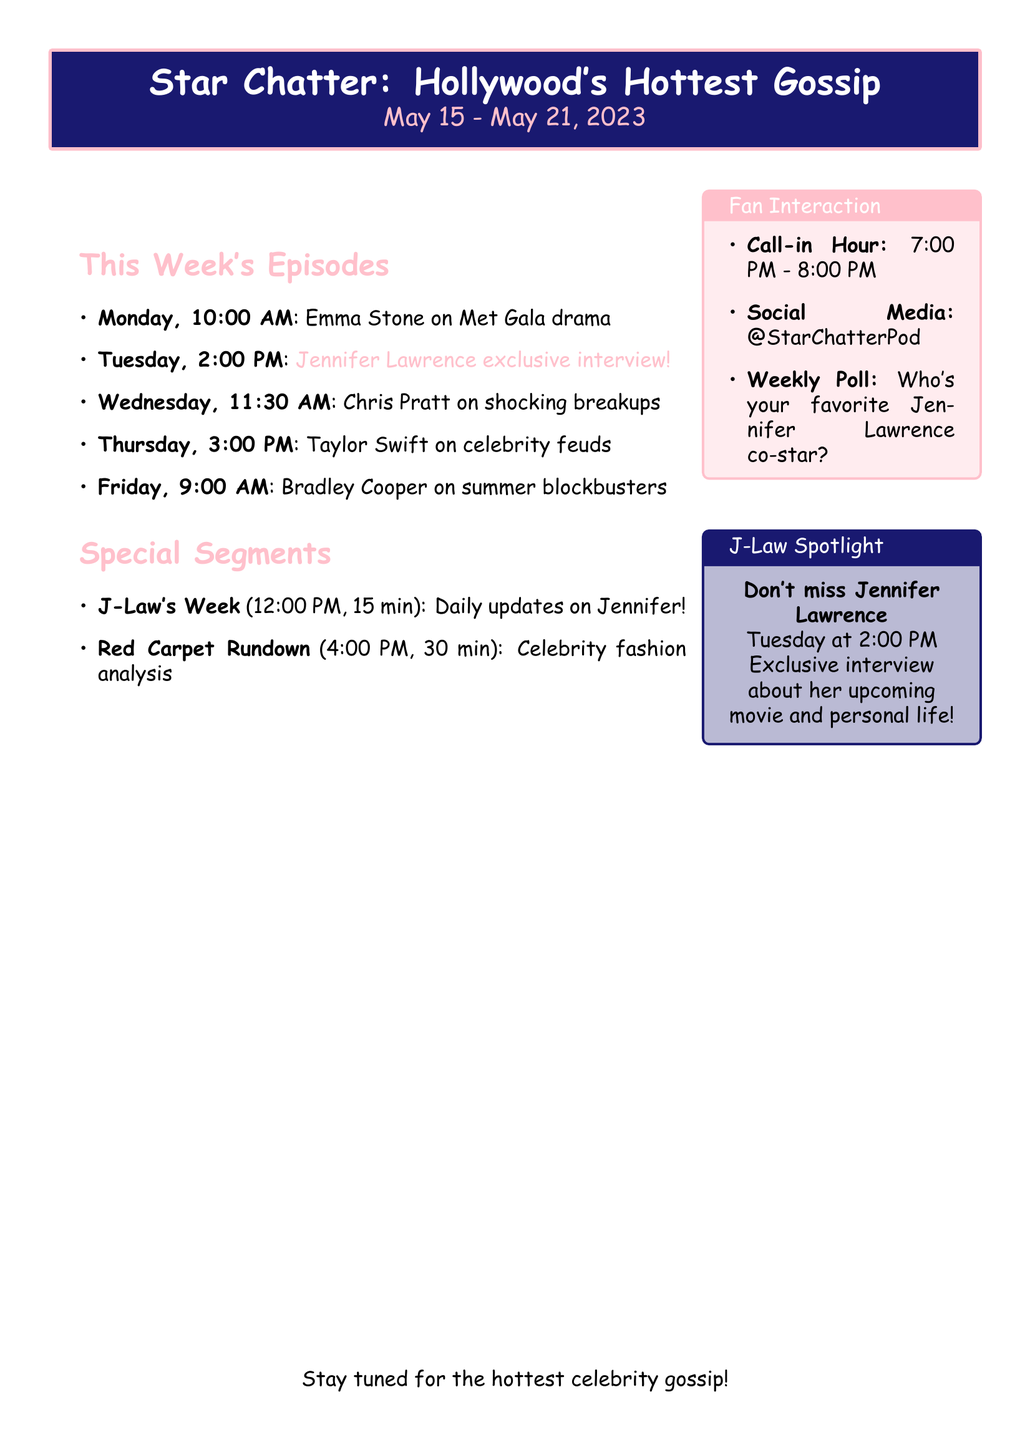What day is Jennifer Lawrence's episode scheduled? Jennifer Lawrence's episode is on Tuesday.
Answer: Tuesday What time is the episode with Emma Stone? The episode with Emma Stone is at 10:00 AM on Monday.
Answer: 10:00 AM Who hosts the episode featuring Chris Pratt? Chris Pratt's episode is hosted by Wendy Williams.
Answer: Wendy Williams What is the topic of the episode with Taylor Swift? The topic of Taylor Swift's episode is about celebrity feuds and social media drama.
Answer: Celebrity feuds and social media drama What is the title of the special segment focusing on Jennifer Lawrence? The special segment focusing on Jennifer Lawrence is called "J-Law's Week."
Answer: J-Law's Week How long is the "Red Carpet Rundown" segment? The "Red Carpet Rundown" segment is 30 minutes long.
Answer: 30 minutes What is the weekly poll question about? The weekly poll question is about fans' favorite co-star of Jennifer Lawrence.
Answer: Who's your favorite Jennifer Lawrence co-star? When is the call-in hour for fan interaction? The call-in hour for fan interaction is from 7:00 PM to 8:00 PM.
Answer: 7:00 PM - 8:00 PM 